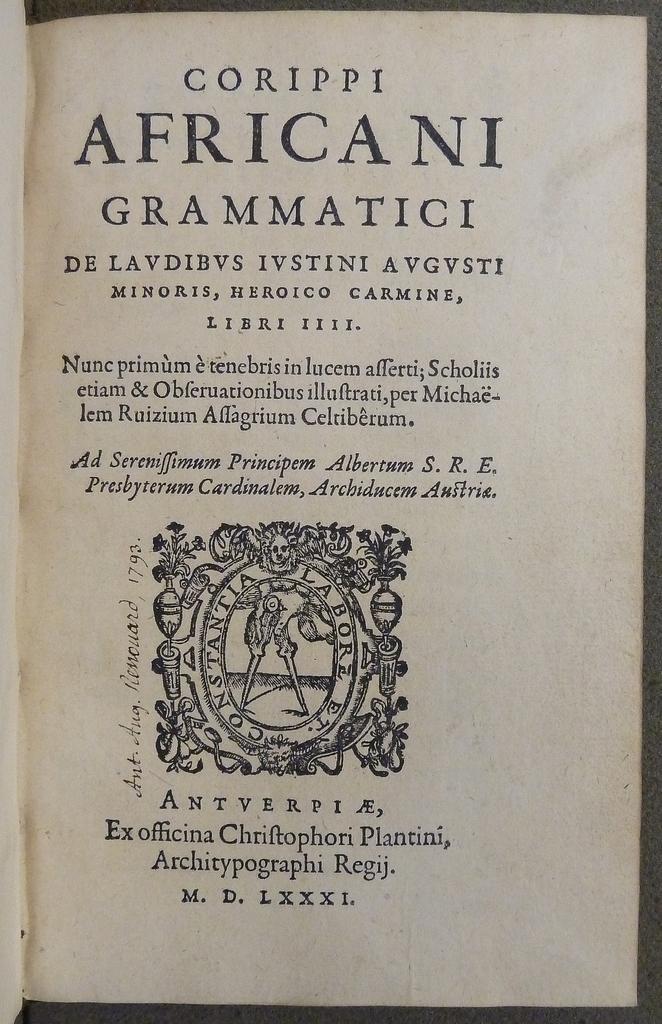<image>
Provide a brief description of the given image. Corippi Africani Grammatici is the title shown for this open book. 